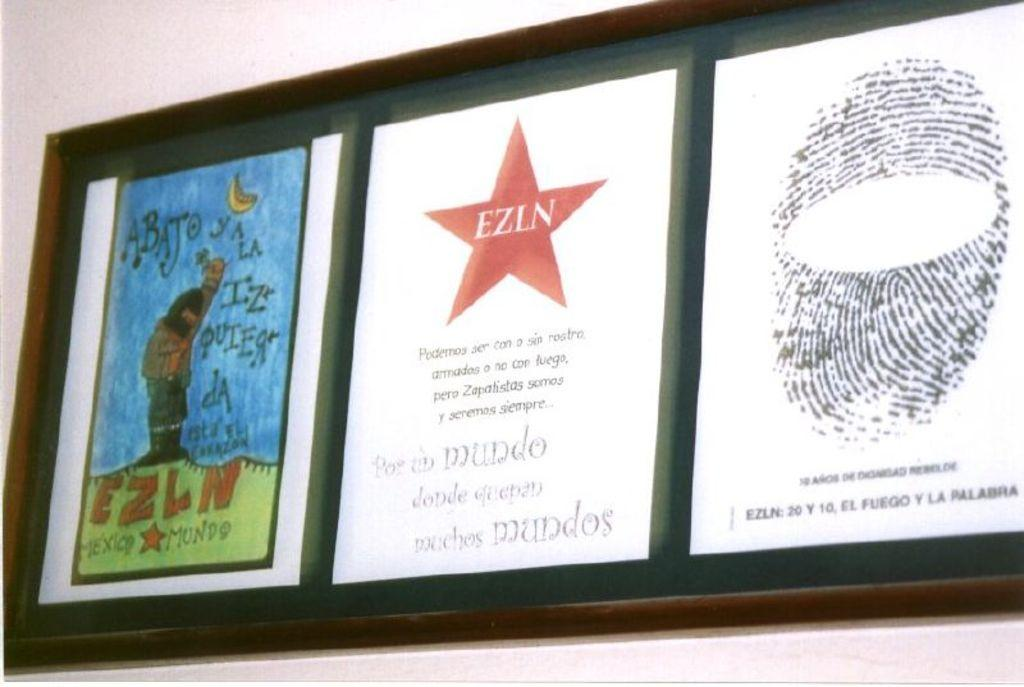Provide a one-sentence caption for the provided image. The middle picture has a red star with the letters EZLN in the middle. 